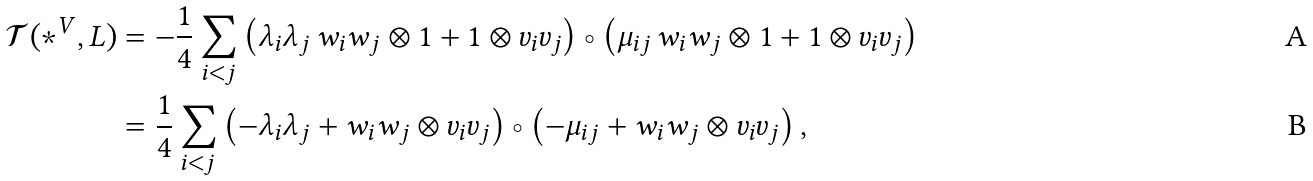Convert formula to latex. <formula><loc_0><loc_0><loc_500><loc_500>\mathcal { T } ( * ^ { V } , L ) & = - \frac { 1 } { 4 } \sum _ { i < j } \left ( \lambda _ { i } \lambda _ { j } \, w _ { i } w _ { j } \otimes 1 + 1 \otimes v _ { i } v _ { j } \right ) \circ \left ( \mu _ { i j } \, w _ { i } w _ { j } \otimes 1 + 1 \otimes v _ { i } v _ { j } \right ) \\ & = \frac { 1 } { 4 } \sum _ { i < j } \left ( - \lambda _ { i } \lambda _ { j } + w _ { i } w _ { j } \otimes v _ { i } v _ { j } \right ) \circ \left ( - \mu _ { i j } + w _ { i } w _ { j } \otimes v _ { i } v _ { j } \right ) ,</formula> 